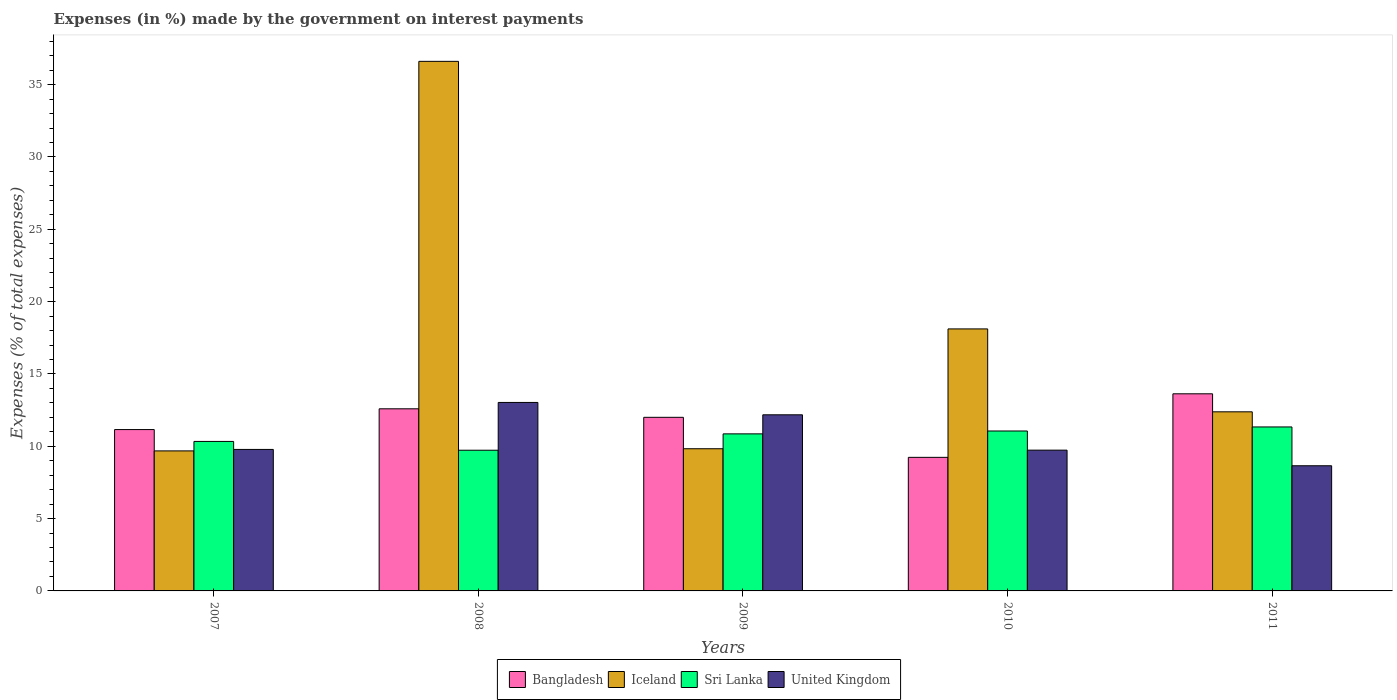How many different coloured bars are there?
Your answer should be very brief. 4. How many groups of bars are there?
Offer a terse response. 5. Are the number of bars per tick equal to the number of legend labels?
Give a very brief answer. Yes. Are the number of bars on each tick of the X-axis equal?
Give a very brief answer. Yes. How many bars are there on the 5th tick from the left?
Give a very brief answer. 4. How many bars are there on the 5th tick from the right?
Ensure brevity in your answer.  4. What is the label of the 2nd group of bars from the left?
Offer a terse response. 2008. In how many cases, is the number of bars for a given year not equal to the number of legend labels?
Keep it short and to the point. 0. What is the percentage of expenses made by the government on interest payments in United Kingdom in 2008?
Make the answer very short. 13.03. Across all years, what is the maximum percentage of expenses made by the government on interest payments in Sri Lanka?
Give a very brief answer. 11.34. Across all years, what is the minimum percentage of expenses made by the government on interest payments in Iceland?
Give a very brief answer. 9.68. In which year was the percentage of expenses made by the government on interest payments in United Kingdom maximum?
Keep it short and to the point. 2008. What is the total percentage of expenses made by the government on interest payments in Iceland in the graph?
Keep it short and to the point. 86.62. What is the difference between the percentage of expenses made by the government on interest payments in United Kingdom in 2010 and that in 2011?
Offer a terse response. 1.08. What is the difference between the percentage of expenses made by the government on interest payments in United Kingdom in 2008 and the percentage of expenses made by the government on interest payments in Sri Lanka in 2009?
Your answer should be compact. 2.17. What is the average percentage of expenses made by the government on interest payments in Bangladesh per year?
Provide a succinct answer. 11.72. In the year 2009, what is the difference between the percentage of expenses made by the government on interest payments in Iceland and percentage of expenses made by the government on interest payments in Bangladesh?
Offer a very short reply. -2.17. What is the ratio of the percentage of expenses made by the government on interest payments in Iceland in 2007 to that in 2009?
Your answer should be compact. 0.98. Is the percentage of expenses made by the government on interest payments in Bangladesh in 2007 less than that in 2011?
Offer a terse response. Yes. What is the difference between the highest and the second highest percentage of expenses made by the government on interest payments in Sri Lanka?
Give a very brief answer. 0.28. What is the difference between the highest and the lowest percentage of expenses made by the government on interest payments in Bangladesh?
Offer a very short reply. 4.39. Is the sum of the percentage of expenses made by the government on interest payments in United Kingdom in 2008 and 2010 greater than the maximum percentage of expenses made by the government on interest payments in Iceland across all years?
Give a very brief answer. No. What does the 1st bar from the left in 2010 represents?
Provide a short and direct response. Bangladesh. What does the 4th bar from the right in 2008 represents?
Offer a very short reply. Bangladesh. Is it the case that in every year, the sum of the percentage of expenses made by the government on interest payments in Sri Lanka and percentage of expenses made by the government on interest payments in Bangladesh is greater than the percentage of expenses made by the government on interest payments in United Kingdom?
Your answer should be compact. Yes. How many bars are there?
Ensure brevity in your answer.  20. Are all the bars in the graph horizontal?
Your answer should be compact. No. How many years are there in the graph?
Keep it short and to the point. 5. What is the difference between two consecutive major ticks on the Y-axis?
Your response must be concise. 5. Are the values on the major ticks of Y-axis written in scientific E-notation?
Offer a very short reply. No. Does the graph contain any zero values?
Give a very brief answer. No. How are the legend labels stacked?
Ensure brevity in your answer.  Horizontal. What is the title of the graph?
Your answer should be compact. Expenses (in %) made by the government on interest payments. Does "India" appear as one of the legend labels in the graph?
Ensure brevity in your answer.  No. What is the label or title of the Y-axis?
Your response must be concise. Expenses (% of total expenses). What is the Expenses (% of total expenses) in Bangladesh in 2007?
Provide a short and direct response. 11.16. What is the Expenses (% of total expenses) in Iceland in 2007?
Your answer should be compact. 9.68. What is the Expenses (% of total expenses) in Sri Lanka in 2007?
Make the answer very short. 10.34. What is the Expenses (% of total expenses) in United Kingdom in 2007?
Give a very brief answer. 9.78. What is the Expenses (% of total expenses) of Bangladesh in 2008?
Keep it short and to the point. 12.59. What is the Expenses (% of total expenses) of Iceland in 2008?
Provide a succinct answer. 36.61. What is the Expenses (% of total expenses) of Sri Lanka in 2008?
Provide a short and direct response. 9.73. What is the Expenses (% of total expenses) of United Kingdom in 2008?
Make the answer very short. 13.03. What is the Expenses (% of total expenses) of Bangladesh in 2009?
Offer a terse response. 12. What is the Expenses (% of total expenses) of Iceland in 2009?
Your answer should be compact. 9.83. What is the Expenses (% of total expenses) in Sri Lanka in 2009?
Offer a very short reply. 10.86. What is the Expenses (% of total expenses) of United Kingdom in 2009?
Your answer should be very brief. 12.18. What is the Expenses (% of total expenses) of Bangladesh in 2010?
Your answer should be compact. 9.23. What is the Expenses (% of total expenses) of Iceland in 2010?
Provide a succinct answer. 18.11. What is the Expenses (% of total expenses) in Sri Lanka in 2010?
Give a very brief answer. 11.06. What is the Expenses (% of total expenses) of United Kingdom in 2010?
Provide a short and direct response. 9.73. What is the Expenses (% of total expenses) of Bangladesh in 2011?
Your response must be concise. 13.63. What is the Expenses (% of total expenses) of Iceland in 2011?
Offer a very short reply. 12.38. What is the Expenses (% of total expenses) of Sri Lanka in 2011?
Keep it short and to the point. 11.34. What is the Expenses (% of total expenses) of United Kingdom in 2011?
Provide a short and direct response. 8.65. Across all years, what is the maximum Expenses (% of total expenses) in Bangladesh?
Your answer should be very brief. 13.63. Across all years, what is the maximum Expenses (% of total expenses) of Iceland?
Provide a succinct answer. 36.61. Across all years, what is the maximum Expenses (% of total expenses) of Sri Lanka?
Provide a short and direct response. 11.34. Across all years, what is the maximum Expenses (% of total expenses) of United Kingdom?
Give a very brief answer. 13.03. Across all years, what is the minimum Expenses (% of total expenses) in Bangladesh?
Your answer should be very brief. 9.23. Across all years, what is the minimum Expenses (% of total expenses) of Iceland?
Provide a succinct answer. 9.68. Across all years, what is the minimum Expenses (% of total expenses) in Sri Lanka?
Offer a very short reply. 9.73. Across all years, what is the minimum Expenses (% of total expenses) of United Kingdom?
Offer a terse response. 8.65. What is the total Expenses (% of total expenses) in Bangladesh in the graph?
Offer a very short reply. 58.61. What is the total Expenses (% of total expenses) of Iceland in the graph?
Give a very brief answer. 86.62. What is the total Expenses (% of total expenses) of Sri Lanka in the graph?
Your response must be concise. 53.31. What is the total Expenses (% of total expenses) of United Kingdom in the graph?
Ensure brevity in your answer.  53.38. What is the difference between the Expenses (% of total expenses) in Bangladesh in 2007 and that in 2008?
Offer a very short reply. -1.44. What is the difference between the Expenses (% of total expenses) in Iceland in 2007 and that in 2008?
Give a very brief answer. -26.93. What is the difference between the Expenses (% of total expenses) in Sri Lanka in 2007 and that in 2008?
Give a very brief answer. 0.61. What is the difference between the Expenses (% of total expenses) of United Kingdom in 2007 and that in 2008?
Offer a very short reply. -3.25. What is the difference between the Expenses (% of total expenses) of Bangladesh in 2007 and that in 2009?
Offer a terse response. -0.85. What is the difference between the Expenses (% of total expenses) of Iceland in 2007 and that in 2009?
Make the answer very short. -0.15. What is the difference between the Expenses (% of total expenses) of Sri Lanka in 2007 and that in 2009?
Your response must be concise. -0.52. What is the difference between the Expenses (% of total expenses) in United Kingdom in 2007 and that in 2009?
Ensure brevity in your answer.  -2.39. What is the difference between the Expenses (% of total expenses) of Bangladesh in 2007 and that in 2010?
Give a very brief answer. 1.92. What is the difference between the Expenses (% of total expenses) in Iceland in 2007 and that in 2010?
Offer a terse response. -8.43. What is the difference between the Expenses (% of total expenses) in Sri Lanka in 2007 and that in 2010?
Your answer should be compact. -0.72. What is the difference between the Expenses (% of total expenses) of United Kingdom in 2007 and that in 2010?
Provide a succinct answer. 0.05. What is the difference between the Expenses (% of total expenses) in Bangladesh in 2007 and that in 2011?
Give a very brief answer. -2.47. What is the difference between the Expenses (% of total expenses) of Iceland in 2007 and that in 2011?
Your answer should be compact. -2.7. What is the difference between the Expenses (% of total expenses) in Sri Lanka in 2007 and that in 2011?
Offer a very short reply. -1. What is the difference between the Expenses (% of total expenses) of United Kingdom in 2007 and that in 2011?
Provide a short and direct response. 1.13. What is the difference between the Expenses (% of total expenses) of Bangladesh in 2008 and that in 2009?
Make the answer very short. 0.59. What is the difference between the Expenses (% of total expenses) of Iceland in 2008 and that in 2009?
Ensure brevity in your answer.  26.78. What is the difference between the Expenses (% of total expenses) of Sri Lanka in 2008 and that in 2009?
Provide a short and direct response. -1.13. What is the difference between the Expenses (% of total expenses) in United Kingdom in 2008 and that in 2009?
Provide a short and direct response. 0.85. What is the difference between the Expenses (% of total expenses) in Bangladesh in 2008 and that in 2010?
Your response must be concise. 3.36. What is the difference between the Expenses (% of total expenses) of Iceland in 2008 and that in 2010?
Keep it short and to the point. 18.5. What is the difference between the Expenses (% of total expenses) in Sri Lanka in 2008 and that in 2010?
Give a very brief answer. -1.33. What is the difference between the Expenses (% of total expenses) of United Kingdom in 2008 and that in 2010?
Provide a succinct answer. 3.3. What is the difference between the Expenses (% of total expenses) in Bangladesh in 2008 and that in 2011?
Provide a short and direct response. -1.04. What is the difference between the Expenses (% of total expenses) of Iceland in 2008 and that in 2011?
Provide a short and direct response. 24.23. What is the difference between the Expenses (% of total expenses) of Sri Lanka in 2008 and that in 2011?
Provide a short and direct response. -1.61. What is the difference between the Expenses (% of total expenses) in United Kingdom in 2008 and that in 2011?
Offer a very short reply. 4.38. What is the difference between the Expenses (% of total expenses) in Bangladesh in 2009 and that in 2010?
Offer a terse response. 2.77. What is the difference between the Expenses (% of total expenses) in Iceland in 2009 and that in 2010?
Provide a short and direct response. -8.28. What is the difference between the Expenses (% of total expenses) in Sri Lanka in 2009 and that in 2010?
Give a very brief answer. -0.2. What is the difference between the Expenses (% of total expenses) of United Kingdom in 2009 and that in 2010?
Ensure brevity in your answer.  2.44. What is the difference between the Expenses (% of total expenses) in Bangladesh in 2009 and that in 2011?
Your response must be concise. -1.63. What is the difference between the Expenses (% of total expenses) of Iceland in 2009 and that in 2011?
Give a very brief answer. -2.55. What is the difference between the Expenses (% of total expenses) of Sri Lanka in 2009 and that in 2011?
Provide a short and direct response. -0.48. What is the difference between the Expenses (% of total expenses) in United Kingdom in 2009 and that in 2011?
Offer a very short reply. 3.52. What is the difference between the Expenses (% of total expenses) of Bangladesh in 2010 and that in 2011?
Ensure brevity in your answer.  -4.39. What is the difference between the Expenses (% of total expenses) in Iceland in 2010 and that in 2011?
Keep it short and to the point. 5.73. What is the difference between the Expenses (% of total expenses) of Sri Lanka in 2010 and that in 2011?
Your response must be concise. -0.28. What is the difference between the Expenses (% of total expenses) of United Kingdom in 2010 and that in 2011?
Give a very brief answer. 1.08. What is the difference between the Expenses (% of total expenses) in Bangladesh in 2007 and the Expenses (% of total expenses) in Iceland in 2008?
Keep it short and to the point. -25.46. What is the difference between the Expenses (% of total expenses) of Bangladesh in 2007 and the Expenses (% of total expenses) of Sri Lanka in 2008?
Offer a terse response. 1.43. What is the difference between the Expenses (% of total expenses) in Bangladesh in 2007 and the Expenses (% of total expenses) in United Kingdom in 2008?
Provide a short and direct response. -1.88. What is the difference between the Expenses (% of total expenses) of Iceland in 2007 and the Expenses (% of total expenses) of Sri Lanka in 2008?
Keep it short and to the point. -0.05. What is the difference between the Expenses (% of total expenses) in Iceland in 2007 and the Expenses (% of total expenses) in United Kingdom in 2008?
Your answer should be compact. -3.35. What is the difference between the Expenses (% of total expenses) in Sri Lanka in 2007 and the Expenses (% of total expenses) in United Kingdom in 2008?
Offer a very short reply. -2.7. What is the difference between the Expenses (% of total expenses) in Bangladesh in 2007 and the Expenses (% of total expenses) in Iceland in 2009?
Your answer should be compact. 1.33. What is the difference between the Expenses (% of total expenses) in Bangladesh in 2007 and the Expenses (% of total expenses) in Sri Lanka in 2009?
Your response must be concise. 0.3. What is the difference between the Expenses (% of total expenses) in Bangladesh in 2007 and the Expenses (% of total expenses) in United Kingdom in 2009?
Your answer should be very brief. -1.02. What is the difference between the Expenses (% of total expenses) of Iceland in 2007 and the Expenses (% of total expenses) of Sri Lanka in 2009?
Offer a very short reply. -1.18. What is the difference between the Expenses (% of total expenses) of Iceland in 2007 and the Expenses (% of total expenses) of United Kingdom in 2009?
Your response must be concise. -2.5. What is the difference between the Expenses (% of total expenses) in Sri Lanka in 2007 and the Expenses (% of total expenses) in United Kingdom in 2009?
Your response must be concise. -1.84. What is the difference between the Expenses (% of total expenses) in Bangladesh in 2007 and the Expenses (% of total expenses) in Iceland in 2010?
Your answer should be very brief. -6.96. What is the difference between the Expenses (% of total expenses) of Bangladesh in 2007 and the Expenses (% of total expenses) of Sri Lanka in 2010?
Make the answer very short. 0.1. What is the difference between the Expenses (% of total expenses) in Bangladesh in 2007 and the Expenses (% of total expenses) in United Kingdom in 2010?
Offer a terse response. 1.42. What is the difference between the Expenses (% of total expenses) in Iceland in 2007 and the Expenses (% of total expenses) in Sri Lanka in 2010?
Your answer should be very brief. -1.38. What is the difference between the Expenses (% of total expenses) in Iceland in 2007 and the Expenses (% of total expenses) in United Kingdom in 2010?
Ensure brevity in your answer.  -0.05. What is the difference between the Expenses (% of total expenses) in Sri Lanka in 2007 and the Expenses (% of total expenses) in United Kingdom in 2010?
Keep it short and to the point. 0.6. What is the difference between the Expenses (% of total expenses) of Bangladesh in 2007 and the Expenses (% of total expenses) of Iceland in 2011?
Your answer should be very brief. -1.23. What is the difference between the Expenses (% of total expenses) in Bangladesh in 2007 and the Expenses (% of total expenses) in Sri Lanka in 2011?
Provide a succinct answer. -0.18. What is the difference between the Expenses (% of total expenses) of Bangladesh in 2007 and the Expenses (% of total expenses) of United Kingdom in 2011?
Ensure brevity in your answer.  2.5. What is the difference between the Expenses (% of total expenses) of Iceland in 2007 and the Expenses (% of total expenses) of Sri Lanka in 2011?
Your answer should be compact. -1.66. What is the difference between the Expenses (% of total expenses) of Iceland in 2007 and the Expenses (% of total expenses) of United Kingdom in 2011?
Keep it short and to the point. 1.03. What is the difference between the Expenses (% of total expenses) in Sri Lanka in 2007 and the Expenses (% of total expenses) in United Kingdom in 2011?
Offer a very short reply. 1.68. What is the difference between the Expenses (% of total expenses) of Bangladesh in 2008 and the Expenses (% of total expenses) of Iceland in 2009?
Provide a short and direct response. 2.76. What is the difference between the Expenses (% of total expenses) of Bangladesh in 2008 and the Expenses (% of total expenses) of Sri Lanka in 2009?
Offer a very short reply. 1.73. What is the difference between the Expenses (% of total expenses) of Bangladesh in 2008 and the Expenses (% of total expenses) of United Kingdom in 2009?
Make the answer very short. 0.41. What is the difference between the Expenses (% of total expenses) in Iceland in 2008 and the Expenses (% of total expenses) in Sri Lanka in 2009?
Ensure brevity in your answer.  25.75. What is the difference between the Expenses (% of total expenses) of Iceland in 2008 and the Expenses (% of total expenses) of United Kingdom in 2009?
Keep it short and to the point. 24.44. What is the difference between the Expenses (% of total expenses) of Sri Lanka in 2008 and the Expenses (% of total expenses) of United Kingdom in 2009?
Offer a terse response. -2.45. What is the difference between the Expenses (% of total expenses) of Bangladesh in 2008 and the Expenses (% of total expenses) of Iceland in 2010?
Your answer should be very brief. -5.52. What is the difference between the Expenses (% of total expenses) in Bangladesh in 2008 and the Expenses (% of total expenses) in Sri Lanka in 2010?
Offer a terse response. 1.53. What is the difference between the Expenses (% of total expenses) in Bangladesh in 2008 and the Expenses (% of total expenses) in United Kingdom in 2010?
Provide a succinct answer. 2.86. What is the difference between the Expenses (% of total expenses) of Iceland in 2008 and the Expenses (% of total expenses) of Sri Lanka in 2010?
Offer a very short reply. 25.55. What is the difference between the Expenses (% of total expenses) of Iceland in 2008 and the Expenses (% of total expenses) of United Kingdom in 2010?
Provide a succinct answer. 26.88. What is the difference between the Expenses (% of total expenses) of Sri Lanka in 2008 and the Expenses (% of total expenses) of United Kingdom in 2010?
Your answer should be compact. -0.01. What is the difference between the Expenses (% of total expenses) in Bangladesh in 2008 and the Expenses (% of total expenses) in Iceland in 2011?
Make the answer very short. 0.21. What is the difference between the Expenses (% of total expenses) of Bangladesh in 2008 and the Expenses (% of total expenses) of Sri Lanka in 2011?
Make the answer very short. 1.25. What is the difference between the Expenses (% of total expenses) of Bangladesh in 2008 and the Expenses (% of total expenses) of United Kingdom in 2011?
Offer a terse response. 3.94. What is the difference between the Expenses (% of total expenses) of Iceland in 2008 and the Expenses (% of total expenses) of Sri Lanka in 2011?
Offer a terse response. 25.28. What is the difference between the Expenses (% of total expenses) of Iceland in 2008 and the Expenses (% of total expenses) of United Kingdom in 2011?
Keep it short and to the point. 27.96. What is the difference between the Expenses (% of total expenses) of Sri Lanka in 2008 and the Expenses (% of total expenses) of United Kingdom in 2011?
Provide a short and direct response. 1.07. What is the difference between the Expenses (% of total expenses) in Bangladesh in 2009 and the Expenses (% of total expenses) in Iceland in 2010?
Provide a succinct answer. -6.11. What is the difference between the Expenses (% of total expenses) of Bangladesh in 2009 and the Expenses (% of total expenses) of Sri Lanka in 2010?
Offer a terse response. 0.94. What is the difference between the Expenses (% of total expenses) in Bangladesh in 2009 and the Expenses (% of total expenses) in United Kingdom in 2010?
Provide a short and direct response. 2.27. What is the difference between the Expenses (% of total expenses) of Iceland in 2009 and the Expenses (% of total expenses) of Sri Lanka in 2010?
Offer a very short reply. -1.23. What is the difference between the Expenses (% of total expenses) in Iceland in 2009 and the Expenses (% of total expenses) in United Kingdom in 2010?
Offer a terse response. 0.1. What is the difference between the Expenses (% of total expenses) in Sri Lanka in 2009 and the Expenses (% of total expenses) in United Kingdom in 2010?
Ensure brevity in your answer.  1.13. What is the difference between the Expenses (% of total expenses) in Bangladesh in 2009 and the Expenses (% of total expenses) in Iceland in 2011?
Keep it short and to the point. -0.38. What is the difference between the Expenses (% of total expenses) of Bangladesh in 2009 and the Expenses (% of total expenses) of Sri Lanka in 2011?
Keep it short and to the point. 0.67. What is the difference between the Expenses (% of total expenses) in Bangladesh in 2009 and the Expenses (% of total expenses) in United Kingdom in 2011?
Offer a very short reply. 3.35. What is the difference between the Expenses (% of total expenses) of Iceland in 2009 and the Expenses (% of total expenses) of Sri Lanka in 2011?
Your response must be concise. -1.51. What is the difference between the Expenses (% of total expenses) of Iceland in 2009 and the Expenses (% of total expenses) of United Kingdom in 2011?
Your response must be concise. 1.18. What is the difference between the Expenses (% of total expenses) of Sri Lanka in 2009 and the Expenses (% of total expenses) of United Kingdom in 2011?
Offer a terse response. 2.21. What is the difference between the Expenses (% of total expenses) in Bangladesh in 2010 and the Expenses (% of total expenses) in Iceland in 2011?
Your response must be concise. -3.15. What is the difference between the Expenses (% of total expenses) of Bangladesh in 2010 and the Expenses (% of total expenses) of Sri Lanka in 2011?
Give a very brief answer. -2.1. What is the difference between the Expenses (% of total expenses) in Bangladesh in 2010 and the Expenses (% of total expenses) in United Kingdom in 2011?
Your response must be concise. 0.58. What is the difference between the Expenses (% of total expenses) in Iceland in 2010 and the Expenses (% of total expenses) in Sri Lanka in 2011?
Provide a short and direct response. 6.78. What is the difference between the Expenses (% of total expenses) in Iceland in 2010 and the Expenses (% of total expenses) in United Kingdom in 2011?
Your answer should be very brief. 9.46. What is the difference between the Expenses (% of total expenses) in Sri Lanka in 2010 and the Expenses (% of total expenses) in United Kingdom in 2011?
Make the answer very short. 2.4. What is the average Expenses (% of total expenses) of Bangladesh per year?
Make the answer very short. 11.72. What is the average Expenses (% of total expenses) of Iceland per year?
Offer a very short reply. 17.32. What is the average Expenses (% of total expenses) of Sri Lanka per year?
Your response must be concise. 10.66. What is the average Expenses (% of total expenses) of United Kingdom per year?
Your answer should be very brief. 10.68. In the year 2007, what is the difference between the Expenses (% of total expenses) in Bangladesh and Expenses (% of total expenses) in Iceland?
Your answer should be very brief. 1.48. In the year 2007, what is the difference between the Expenses (% of total expenses) in Bangladesh and Expenses (% of total expenses) in Sri Lanka?
Give a very brief answer. 0.82. In the year 2007, what is the difference between the Expenses (% of total expenses) in Bangladesh and Expenses (% of total expenses) in United Kingdom?
Make the answer very short. 1.37. In the year 2007, what is the difference between the Expenses (% of total expenses) of Iceland and Expenses (% of total expenses) of Sri Lanka?
Give a very brief answer. -0.65. In the year 2007, what is the difference between the Expenses (% of total expenses) in Iceland and Expenses (% of total expenses) in United Kingdom?
Your answer should be very brief. -0.1. In the year 2007, what is the difference between the Expenses (% of total expenses) of Sri Lanka and Expenses (% of total expenses) of United Kingdom?
Give a very brief answer. 0.55. In the year 2008, what is the difference between the Expenses (% of total expenses) in Bangladesh and Expenses (% of total expenses) in Iceland?
Your answer should be very brief. -24.02. In the year 2008, what is the difference between the Expenses (% of total expenses) in Bangladesh and Expenses (% of total expenses) in Sri Lanka?
Provide a short and direct response. 2.86. In the year 2008, what is the difference between the Expenses (% of total expenses) of Bangladesh and Expenses (% of total expenses) of United Kingdom?
Keep it short and to the point. -0.44. In the year 2008, what is the difference between the Expenses (% of total expenses) of Iceland and Expenses (% of total expenses) of Sri Lanka?
Provide a succinct answer. 26.89. In the year 2008, what is the difference between the Expenses (% of total expenses) in Iceland and Expenses (% of total expenses) in United Kingdom?
Your response must be concise. 23.58. In the year 2008, what is the difference between the Expenses (% of total expenses) in Sri Lanka and Expenses (% of total expenses) in United Kingdom?
Your answer should be very brief. -3.3. In the year 2009, what is the difference between the Expenses (% of total expenses) in Bangladesh and Expenses (% of total expenses) in Iceland?
Keep it short and to the point. 2.17. In the year 2009, what is the difference between the Expenses (% of total expenses) in Bangladesh and Expenses (% of total expenses) in Sri Lanka?
Provide a short and direct response. 1.14. In the year 2009, what is the difference between the Expenses (% of total expenses) of Bangladesh and Expenses (% of total expenses) of United Kingdom?
Make the answer very short. -0.17. In the year 2009, what is the difference between the Expenses (% of total expenses) of Iceland and Expenses (% of total expenses) of Sri Lanka?
Keep it short and to the point. -1.03. In the year 2009, what is the difference between the Expenses (% of total expenses) in Iceland and Expenses (% of total expenses) in United Kingdom?
Provide a succinct answer. -2.35. In the year 2009, what is the difference between the Expenses (% of total expenses) in Sri Lanka and Expenses (% of total expenses) in United Kingdom?
Your answer should be very brief. -1.32. In the year 2010, what is the difference between the Expenses (% of total expenses) in Bangladesh and Expenses (% of total expenses) in Iceland?
Keep it short and to the point. -8.88. In the year 2010, what is the difference between the Expenses (% of total expenses) in Bangladesh and Expenses (% of total expenses) in Sri Lanka?
Offer a very short reply. -1.82. In the year 2010, what is the difference between the Expenses (% of total expenses) of Bangladesh and Expenses (% of total expenses) of United Kingdom?
Your answer should be compact. -0.5. In the year 2010, what is the difference between the Expenses (% of total expenses) of Iceland and Expenses (% of total expenses) of Sri Lanka?
Your answer should be compact. 7.06. In the year 2010, what is the difference between the Expenses (% of total expenses) in Iceland and Expenses (% of total expenses) in United Kingdom?
Keep it short and to the point. 8.38. In the year 2010, what is the difference between the Expenses (% of total expenses) in Sri Lanka and Expenses (% of total expenses) in United Kingdom?
Provide a short and direct response. 1.32. In the year 2011, what is the difference between the Expenses (% of total expenses) of Bangladesh and Expenses (% of total expenses) of Iceland?
Your answer should be compact. 1.25. In the year 2011, what is the difference between the Expenses (% of total expenses) of Bangladesh and Expenses (% of total expenses) of Sri Lanka?
Ensure brevity in your answer.  2.29. In the year 2011, what is the difference between the Expenses (% of total expenses) of Bangladesh and Expenses (% of total expenses) of United Kingdom?
Give a very brief answer. 4.97. In the year 2011, what is the difference between the Expenses (% of total expenses) of Iceland and Expenses (% of total expenses) of Sri Lanka?
Provide a short and direct response. 1.05. In the year 2011, what is the difference between the Expenses (% of total expenses) in Iceland and Expenses (% of total expenses) in United Kingdom?
Provide a succinct answer. 3.73. In the year 2011, what is the difference between the Expenses (% of total expenses) of Sri Lanka and Expenses (% of total expenses) of United Kingdom?
Keep it short and to the point. 2.68. What is the ratio of the Expenses (% of total expenses) of Bangladesh in 2007 to that in 2008?
Ensure brevity in your answer.  0.89. What is the ratio of the Expenses (% of total expenses) of Iceland in 2007 to that in 2008?
Give a very brief answer. 0.26. What is the ratio of the Expenses (% of total expenses) in Sri Lanka in 2007 to that in 2008?
Provide a short and direct response. 1.06. What is the ratio of the Expenses (% of total expenses) in United Kingdom in 2007 to that in 2008?
Offer a terse response. 0.75. What is the ratio of the Expenses (% of total expenses) in Bangladesh in 2007 to that in 2009?
Offer a very short reply. 0.93. What is the ratio of the Expenses (% of total expenses) in Sri Lanka in 2007 to that in 2009?
Make the answer very short. 0.95. What is the ratio of the Expenses (% of total expenses) in United Kingdom in 2007 to that in 2009?
Keep it short and to the point. 0.8. What is the ratio of the Expenses (% of total expenses) of Bangladesh in 2007 to that in 2010?
Your response must be concise. 1.21. What is the ratio of the Expenses (% of total expenses) in Iceland in 2007 to that in 2010?
Your response must be concise. 0.53. What is the ratio of the Expenses (% of total expenses) of Sri Lanka in 2007 to that in 2010?
Provide a short and direct response. 0.93. What is the ratio of the Expenses (% of total expenses) in United Kingdom in 2007 to that in 2010?
Your answer should be very brief. 1.01. What is the ratio of the Expenses (% of total expenses) of Bangladesh in 2007 to that in 2011?
Ensure brevity in your answer.  0.82. What is the ratio of the Expenses (% of total expenses) of Iceland in 2007 to that in 2011?
Keep it short and to the point. 0.78. What is the ratio of the Expenses (% of total expenses) of Sri Lanka in 2007 to that in 2011?
Your answer should be very brief. 0.91. What is the ratio of the Expenses (% of total expenses) in United Kingdom in 2007 to that in 2011?
Give a very brief answer. 1.13. What is the ratio of the Expenses (% of total expenses) of Bangladesh in 2008 to that in 2009?
Provide a short and direct response. 1.05. What is the ratio of the Expenses (% of total expenses) of Iceland in 2008 to that in 2009?
Give a very brief answer. 3.72. What is the ratio of the Expenses (% of total expenses) in Sri Lanka in 2008 to that in 2009?
Offer a terse response. 0.9. What is the ratio of the Expenses (% of total expenses) of United Kingdom in 2008 to that in 2009?
Make the answer very short. 1.07. What is the ratio of the Expenses (% of total expenses) of Bangladesh in 2008 to that in 2010?
Offer a very short reply. 1.36. What is the ratio of the Expenses (% of total expenses) in Iceland in 2008 to that in 2010?
Give a very brief answer. 2.02. What is the ratio of the Expenses (% of total expenses) of Sri Lanka in 2008 to that in 2010?
Make the answer very short. 0.88. What is the ratio of the Expenses (% of total expenses) in United Kingdom in 2008 to that in 2010?
Offer a very short reply. 1.34. What is the ratio of the Expenses (% of total expenses) in Bangladesh in 2008 to that in 2011?
Offer a very short reply. 0.92. What is the ratio of the Expenses (% of total expenses) in Iceland in 2008 to that in 2011?
Your answer should be very brief. 2.96. What is the ratio of the Expenses (% of total expenses) in Sri Lanka in 2008 to that in 2011?
Give a very brief answer. 0.86. What is the ratio of the Expenses (% of total expenses) in United Kingdom in 2008 to that in 2011?
Provide a succinct answer. 1.51. What is the ratio of the Expenses (% of total expenses) of Bangladesh in 2009 to that in 2010?
Give a very brief answer. 1.3. What is the ratio of the Expenses (% of total expenses) in Iceland in 2009 to that in 2010?
Make the answer very short. 0.54. What is the ratio of the Expenses (% of total expenses) in Sri Lanka in 2009 to that in 2010?
Your answer should be compact. 0.98. What is the ratio of the Expenses (% of total expenses) of United Kingdom in 2009 to that in 2010?
Keep it short and to the point. 1.25. What is the ratio of the Expenses (% of total expenses) of Bangladesh in 2009 to that in 2011?
Your answer should be very brief. 0.88. What is the ratio of the Expenses (% of total expenses) in Iceland in 2009 to that in 2011?
Provide a succinct answer. 0.79. What is the ratio of the Expenses (% of total expenses) in Sri Lanka in 2009 to that in 2011?
Make the answer very short. 0.96. What is the ratio of the Expenses (% of total expenses) in United Kingdom in 2009 to that in 2011?
Make the answer very short. 1.41. What is the ratio of the Expenses (% of total expenses) of Bangladesh in 2010 to that in 2011?
Your answer should be very brief. 0.68. What is the ratio of the Expenses (% of total expenses) of Iceland in 2010 to that in 2011?
Your response must be concise. 1.46. What is the ratio of the Expenses (% of total expenses) of Sri Lanka in 2010 to that in 2011?
Ensure brevity in your answer.  0.98. What is the ratio of the Expenses (% of total expenses) of United Kingdom in 2010 to that in 2011?
Your answer should be compact. 1.12. What is the difference between the highest and the second highest Expenses (% of total expenses) in Bangladesh?
Provide a short and direct response. 1.04. What is the difference between the highest and the second highest Expenses (% of total expenses) of Iceland?
Make the answer very short. 18.5. What is the difference between the highest and the second highest Expenses (% of total expenses) of Sri Lanka?
Make the answer very short. 0.28. What is the difference between the highest and the second highest Expenses (% of total expenses) of United Kingdom?
Offer a terse response. 0.85. What is the difference between the highest and the lowest Expenses (% of total expenses) in Bangladesh?
Offer a terse response. 4.39. What is the difference between the highest and the lowest Expenses (% of total expenses) of Iceland?
Provide a short and direct response. 26.93. What is the difference between the highest and the lowest Expenses (% of total expenses) of Sri Lanka?
Your answer should be compact. 1.61. What is the difference between the highest and the lowest Expenses (% of total expenses) of United Kingdom?
Provide a short and direct response. 4.38. 